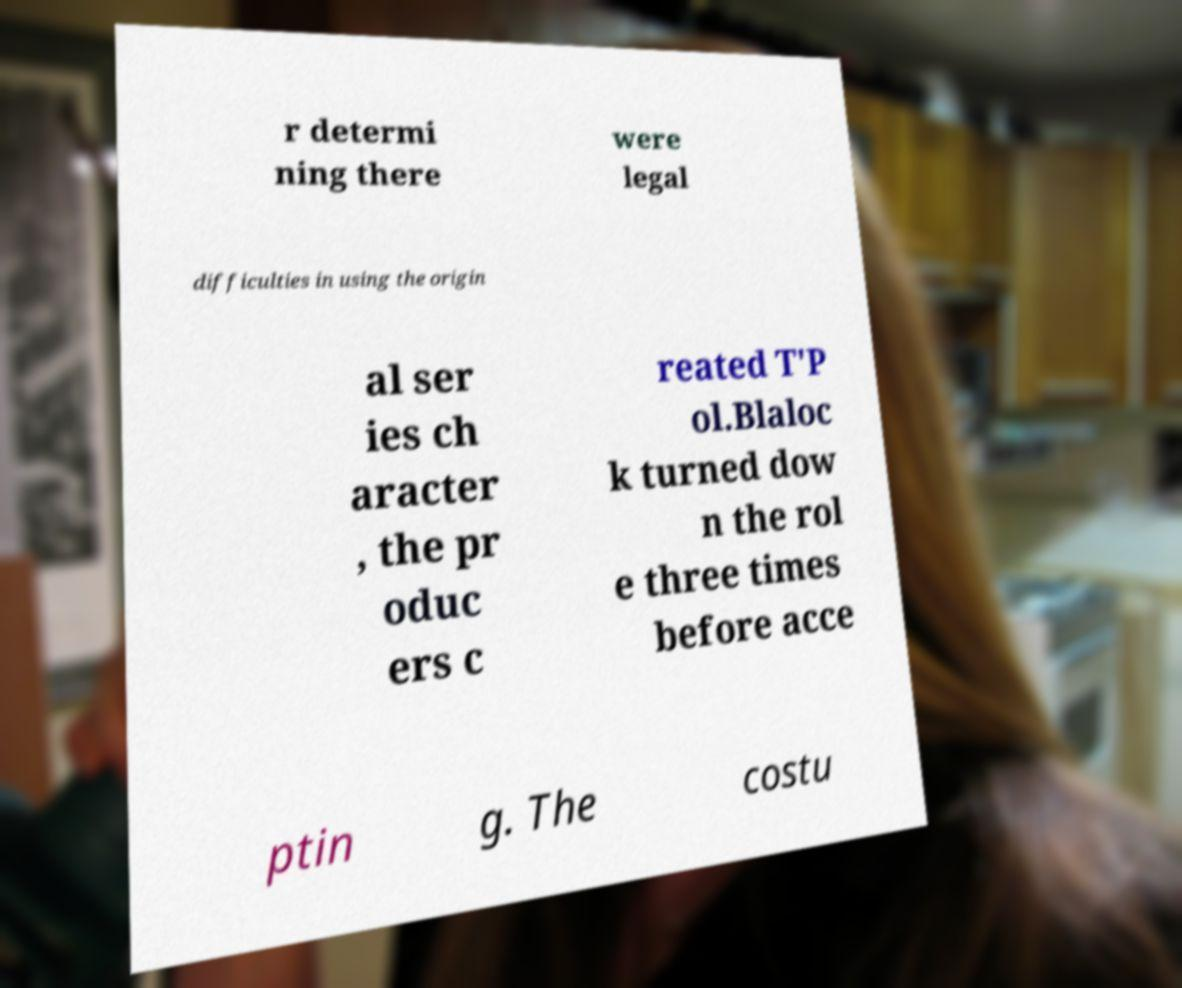Please read and relay the text visible in this image. What does it say? r determi ning there were legal difficulties in using the origin al ser ies ch aracter , the pr oduc ers c reated T'P ol.Blaloc k turned dow n the rol e three times before acce ptin g. The costu 